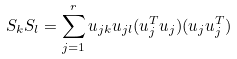Convert formula to latex. <formula><loc_0><loc_0><loc_500><loc_500>S _ { k } S _ { l } = \sum _ { j = 1 } ^ { r } u _ { j k } u _ { j l } ( u _ { j } ^ { T } u _ { j } ) ( u _ { j } u _ { j } ^ { T } )</formula> 